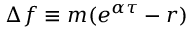Convert formula to latex. <formula><loc_0><loc_0><loc_500><loc_500>\Delta f \equiv m ( e ^ { \alpha \tau } - r )</formula> 